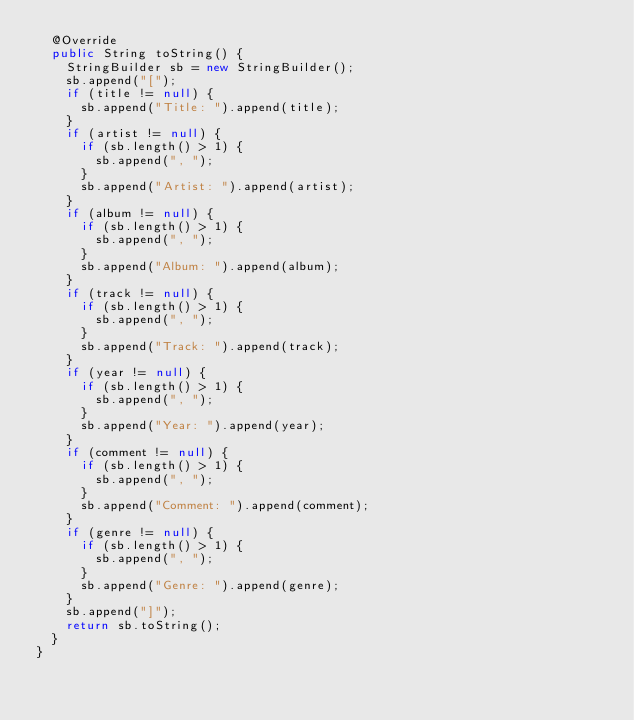Convert code to text. <code><loc_0><loc_0><loc_500><loc_500><_Java_>  @Override
  public String toString() {
    StringBuilder sb = new StringBuilder();
    sb.append("[");
    if (title != null) {
      sb.append("Title: ").append(title);
    }
    if (artist != null) {
      if (sb.length() > 1) {
        sb.append(", ");
      }
      sb.append("Artist: ").append(artist);
    }
    if (album != null) {
      if (sb.length() > 1) {
        sb.append(", ");
      }
      sb.append("Album: ").append(album);
    }
    if (track != null) {
      if (sb.length() > 1) {
        sb.append(", ");
      }
      sb.append("Track: ").append(track);
    }
    if (year != null) {
      if (sb.length() > 1) {
        sb.append(", ");
      }
      sb.append("Year: ").append(year);
    }
    if (comment != null) {
      if (sb.length() > 1) {
        sb.append(", ");
      }
      sb.append("Comment: ").append(comment);
    }
    if (genre != null) {
      if (sb.length() > 1) {
        sb.append(", ");
      }
      sb.append("Genre: ").append(genre);
    }
    sb.append("]");
    return sb.toString();
  }
}
</code> 